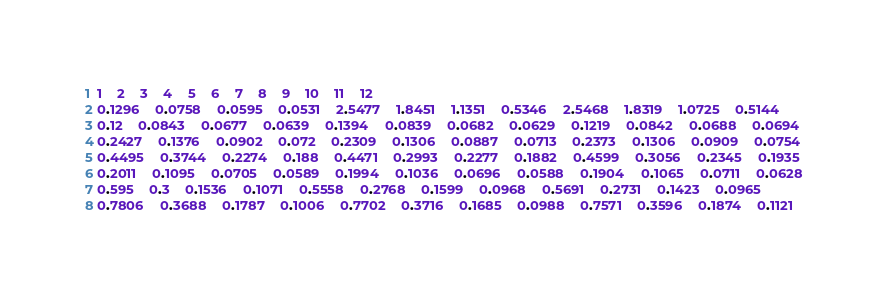<code> <loc_0><loc_0><loc_500><loc_500><_SQL_>1	2	3	4	5	6	7	8	9	10	11	12
0.1296	0.0758	0.0595	0.0531	2.5477	1.8451	1.1351	0.5346	2.5468	1.8319	1.0725	0.5144
0.12	0.0843	0.0677	0.0639	0.1394	0.0839	0.0682	0.0629	0.1219	0.0842	0.0688	0.0694
0.2427	0.1376	0.0902	0.072	0.2309	0.1306	0.0887	0.0713	0.2373	0.1306	0.0909	0.0754
0.4495	0.3744	0.2274	0.188	0.4471	0.2993	0.2277	0.1882	0.4599	0.3056	0.2345	0.1935
0.2011	0.1095	0.0705	0.0589	0.1994	0.1036	0.0696	0.0588	0.1904	0.1065	0.0711	0.0628
0.595	0.3	0.1536	0.1071	0.5558	0.2768	0.1599	0.0968	0.5691	0.2731	0.1423	0.0965
0.7806	0.3688	0.1787	0.1006	0.7702	0.3716	0.1685	0.0988	0.7571	0.3596	0.1874	0.1121</code> 